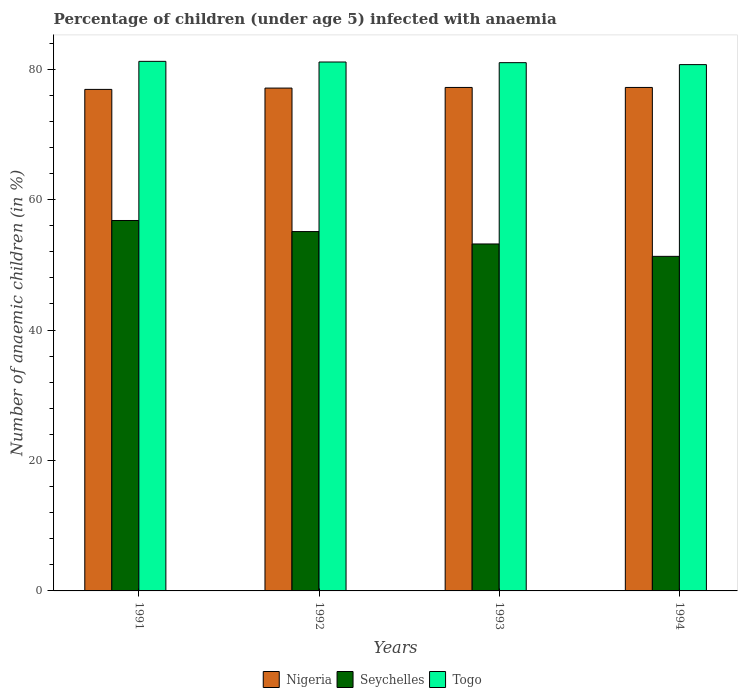How many different coloured bars are there?
Your response must be concise. 3. Are the number of bars per tick equal to the number of legend labels?
Keep it short and to the point. Yes. Are the number of bars on each tick of the X-axis equal?
Keep it short and to the point. Yes. How many bars are there on the 4th tick from the left?
Offer a very short reply. 3. What is the label of the 4th group of bars from the left?
Keep it short and to the point. 1994. Across all years, what is the maximum percentage of children infected with anaemia in in Nigeria?
Your answer should be very brief. 77.2. Across all years, what is the minimum percentage of children infected with anaemia in in Seychelles?
Offer a terse response. 51.3. In which year was the percentage of children infected with anaemia in in Nigeria minimum?
Your answer should be very brief. 1991. What is the total percentage of children infected with anaemia in in Nigeria in the graph?
Provide a succinct answer. 308.4. What is the difference between the percentage of children infected with anaemia in in Seychelles in 1992 and that in 1993?
Offer a terse response. 1.9. What is the difference between the percentage of children infected with anaemia in in Seychelles in 1992 and the percentage of children infected with anaemia in in Togo in 1991?
Offer a terse response. -26.1. What is the average percentage of children infected with anaemia in in Seychelles per year?
Offer a terse response. 54.1. In the year 1994, what is the difference between the percentage of children infected with anaemia in in Nigeria and percentage of children infected with anaemia in in Seychelles?
Offer a terse response. 25.9. In how many years, is the percentage of children infected with anaemia in in Seychelles greater than 76 %?
Give a very brief answer. 0. What is the ratio of the percentage of children infected with anaemia in in Togo in 1991 to that in 1992?
Make the answer very short. 1. Is the difference between the percentage of children infected with anaemia in in Nigeria in 1992 and 1994 greater than the difference between the percentage of children infected with anaemia in in Seychelles in 1992 and 1994?
Your response must be concise. No. What is the difference between the highest and the second highest percentage of children infected with anaemia in in Seychelles?
Provide a succinct answer. 1.7. What is the difference between the highest and the lowest percentage of children infected with anaemia in in Togo?
Offer a terse response. 0.5. In how many years, is the percentage of children infected with anaemia in in Togo greater than the average percentage of children infected with anaemia in in Togo taken over all years?
Make the answer very short. 2. What does the 1st bar from the left in 1991 represents?
Make the answer very short. Nigeria. What does the 2nd bar from the right in 1992 represents?
Provide a short and direct response. Seychelles. How many bars are there?
Make the answer very short. 12. Are all the bars in the graph horizontal?
Give a very brief answer. No. How many years are there in the graph?
Make the answer very short. 4. What is the difference between two consecutive major ticks on the Y-axis?
Provide a succinct answer. 20. Are the values on the major ticks of Y-axis written in scientific E-notation?
Provide a short and direct response. No. Does the graph contain grids?
Your answer should be compact. No. How are the legend labels stacked?
Your answer should be very brief. Horizontal. What is the title of the graph?
Provide a succinct answer. Percentage of children (under age 5) infected with anaemia. What is the label or title of the Y-axis?
Give a very brief answer. Number of anaemic children (in %). What is the Number of anaemic children (in %) of Nigeria in 1991?
Ensure brevity in your answer.  76.9. What is the Number of anaemic children (in %) in Seychelles in 1991?
Ensure brevity in your answer.  56.8. What is the Number of anaemic children (in %) of Togo in 1991?
Keep it short and to the point. 81.2. What is the Number of anaemic children (in %) of Nigeria in 1992?
Make the answer very short. 77.1. What is the Number of anaemic children (in %) in Seychelles in 1992?
Offer a very short reply. 55.1. What is the Number of anaemic children (in %) of Togo in 1992?
Give a very brief answer. 81.1. What is the Number of anaemic children (in %) in Nigeria in 1993?
Make the answer very short. 77.2. What is the Number of anaemic children (in %) in Seychelles in 1993?
Your answer should be very brief. 53.2. What is the Number of anaemic children (in %) in Togo in 1993?
Provide a short and direct response. 81. What is the Number of anaemic children (in %) in Nigeria in 1994?
Make the answer very short. 77.2. What is the Number of anaemic children (in %) of Seychelles in 1994?
Provide a short and direct response. 51.3. What is the Number of anaemic children (in %) in Togo in 1994?
Your answer should be compact. 80.7. Across all years, what is the maximum Number of anaemic children (in %) in Nigeria?
Give a very brief answer. 77.2. Across all years, what is the maximum Number of anaemic children (in %) of Seychelles?
Your answer should be very brief. 56.8. Across all years, what is the maximum Number of anaemic children (in %) of Togo?
Your answer should be very brief. 81.2. Across all years, what is the minimum Number of anaemic children (in %) of Nigeria?
Offer a very short reply. 76.9. Across all years, what is the minimum Number of anaemic children (in %) of Seychelles?
Provide a succinct answer. 51.3. Across all years, what is the minimum Number of anaemic children (in %) in Togo?
Provide a succinct answer. 80.7. What is the total Number of anaemic children (in %) of Nigeria in the graph?
Ensure brevity in your answer.  308.4. What is the total Number of anaemic children (in %) in Seychelles in the graph?
Provide a succinct answer. 216.4. What is the total Number of anaemic children (in %) in Togo in the graph?
Give a very brief answer. 324. What is the difference between the Number of anaemic children (in %) in Seychelles in 1991 and that in 1992?
Offer a terse response. 1.7. What is the difference between the Number of anaemic children (in %) of Seychelles in 1991 and that in 1993?
Your response must be concise. 3.6. What is the difference between the Number of anaemic children (in %) in Togo in 1991 and that in 1993?
Provide a short and direct response. 0.2. What is the difference between the Number of anaemic children (in %) in Nigeria in 1991 and that in 1994?
Keep it short and to the point. -0.3. What is the difference between the Number of anaemic children (in %) in Seychelles in 1992 and that in 1993?
Provide a succinct answer. 1.9. What is the difference between the Number of anaemic children (in %) of Nigeria in 1991 and the Number of anaemic children (in %) of Seychelles in 1992?
Provide a short and direct response. 21.8. What is the difference between the Number of anaemic children (in %) in Nigeria in 1991 and the Number of anaemic children (in %) in Togo in 1992?
Offer a very short reply. -4.2. What is the difference between the Number of anaemic children (in %) of Seychelles in 1991 and the Number of anaemic children (in %) of Togo in 1992?
Keep it short and to the point. -24.3. What is the difference between the Number of anaemic children (in %) of Nigeria in 1991 and the Number of anaemic children (in %) of Seychelles in 1993?
Your answer should be very brief. 23.7. What is the difference between the Number of anaemic children (in %) of Nigeria in 1991 and the Number of anaemic children (in %) of Togo in 1993?
Offer a terse response. -4.1. What is the difference between the Number of anaemic children (in %) of Seychelles in 1991 and the Number of anaemic children (in %) of Togo in 1993?
Offer a very short reply. -24.2. What is the difference between the Number of anaemic children (in %) of Nigeria in 1991 and the Number of anaemic children (in %) of Seychelles in 1994?
Offer a terse response. 25.6. What is the difference between the Number of anaemic children (in %) in Seychelles in 1991 and the Number of anaemic children (in %) in Togo in 1994?
Provide a short and direct response. -23.9. What is the difference between the Number of anaemic children (in %) in Nigeria in 1992 and the Number of anaemic children (in %) in Seychelles in 1993?
Provide a succinct answer. 23.9. What is the difference between the Number of anaemic children (in %) of Nigeria in 1992 and the Number of anaemic children (in %) of Togo in 1993?
Make the answer very short. -3.9. What is the difference between the Number of anaemic children (in %) of Seychelles in 1992 and the Number of anaemic children (in %) of Togo in 1993?
Make the answer very short. -25.9. What is the difference between the Number of anaemic children (in %) in Nigeria in 1992 and the Number of anaemic children (in %) in Seychelles in 1994?
Offer a very short reply. 25.8. What is the difference between the Number of anaemic children (in %) of Nigeria in 1992 and the Number of anaemic children (in %) of Togo in 1994?
Offer a very short reply. -3.6. What is the difference between the Number of anaemic children (in %) in Seychelles in 1992 and the Number of anaemic children (in %) in Togo in 1994?
Ensure brevity in your answer.  -25.6. What is the difference between the Number of anaemic children (in %) in Nigeria in 1993 and the Number of anaemic children (in %) in Seychelles in 1994?
Offer a very short reply. 25.9. What is the difference between the Number of anaemic children (in %) in Seychelles in 1993 and the Number of anaemic children (in %) in Togo in 1994?
Your answer should be compact. -27.5. What is the average Number of anaemic children (in %) of Nigeria per year?
Provide a succinct answer. 77.1. What is the average Number of anaemic children (in %) in Seychelles per year?
Provide a succinct answer. 54.1. What is the average Number of anaemic children (in %) in Togo per year?
Provide a short and direct response. 81. In the year 1991, what is the difference between the Number of anaemic children (in %) of Nigeria and Number of anaemic children (in %) of Seychelles?
Provide a short and direct response. 20.1. In the year 1991, what is the difference between the Number of anaemic children (in %) of Nigeria and Number of anaemic children (in %) of Togo?
Offer a terse response. -4.3. In the year 1991, what is the difference between the Number of anaemic children (in %) in Seychelles and Number of anaemic children (in %) in Togo?
Give a very brief answer. -24.4. In the year 1992, what is the difference between the Number of anaemic children (in %) in Nigeria and Number of anaemic children (in %) in Seychelles?
Ensure brevity in your answer.  22. In the year 1993, what is the difference between the Number of anaemic children (in %) of Nigeria and Number of anaemic children (in %) of Seychelles?
Provide a short and direct response. 24. In the year 1993, what is the difference between the Number of anaemic children (in %) in Seychelles and Number of anaemic children (in %) in Togo?
Ensure brevity in your answer.  -27.8. In the year 1994, what is the difference between the Number of anaemic children (in %) in Nigeria and Number of anaemic children (in %) in Seychelles?
Offer a very short reply. 25.9. In the year 1994, what is the difference between the Number of anaemic children (in %) in Nigeria and Number of anaemic children (in %) in Togo?
Give a very brief answer. -3.5. In the year 1994, what is the difference between the Number of anaemic children (in %) in Seychelles and Number of anaemic children (in %) in Togo?
Your answer should be compact. -29.4. What is the ratio of the Number of anaemic children (in %) of Nigeria in 1991 to that in 1992?
Give a very brief answer. 1. What is the ratio of the Number of anaemic children (in %) in Seychelles in 1991 to that in 1992?
Make the answer very short. 1.03. What is the ratio of the Number of anaemic children (in %) in Togo in 1991 to that in 1992?
Offer a terse response. 1. What is the ratio of the Number of anaemic children (in %) in Seychelles in 1991 to that in 1993?
Ensure brevity in your answer.  1.07. What is the ratio of the Number of anaemic children (in %) of Nigeria in 1991 to that in 1994?
Offer a terse response. 1. What is the ratio of the Number of anaemic children (in %) of Seychelles in 1991 to that in 1994?
Offer a terse response. 1.11. What is the ratio of the Number of anaemic children (in %) of Togo in 1991 to that in 1994?
Offer a terse response. 1.01. What is the ratio of the Number of anaemic children (in %) of Seychelles in 1992 to that in 1993?
Offer a terse response. 1.04. What is the ratio of the Number of anaemic children (in %) of Togo in 1992 to that in 1993?
Keep it short and to the point. 1. What is the ratio of the Number of anaemic children (in %) in Seychelles in 1992 to that in 1994?
Your answer should be compact. 1.07. What is the ratio of the Number of anaemic children (in %) of Togo in 1992 to that in 1994?
Keep it short and to the point. 1. What is the ratio of the Number of anaemic children (in %) of Nigeria in 1993 to that in 1994?
Offer a terse response. 1. What is the difference between the highest and the second highest Number of anaemic children (in %) in Seychelles?
Ensure brevity in your answer.  1.7. What is the difference between the highest and the second highest Number of anaemic children (in %) in Togo?
Your answer should be compact. 0.1. What is the difference between the highest and the lowest Number of anaemic children (in %) in Togo?
Give a very brief answer. 0.5. 